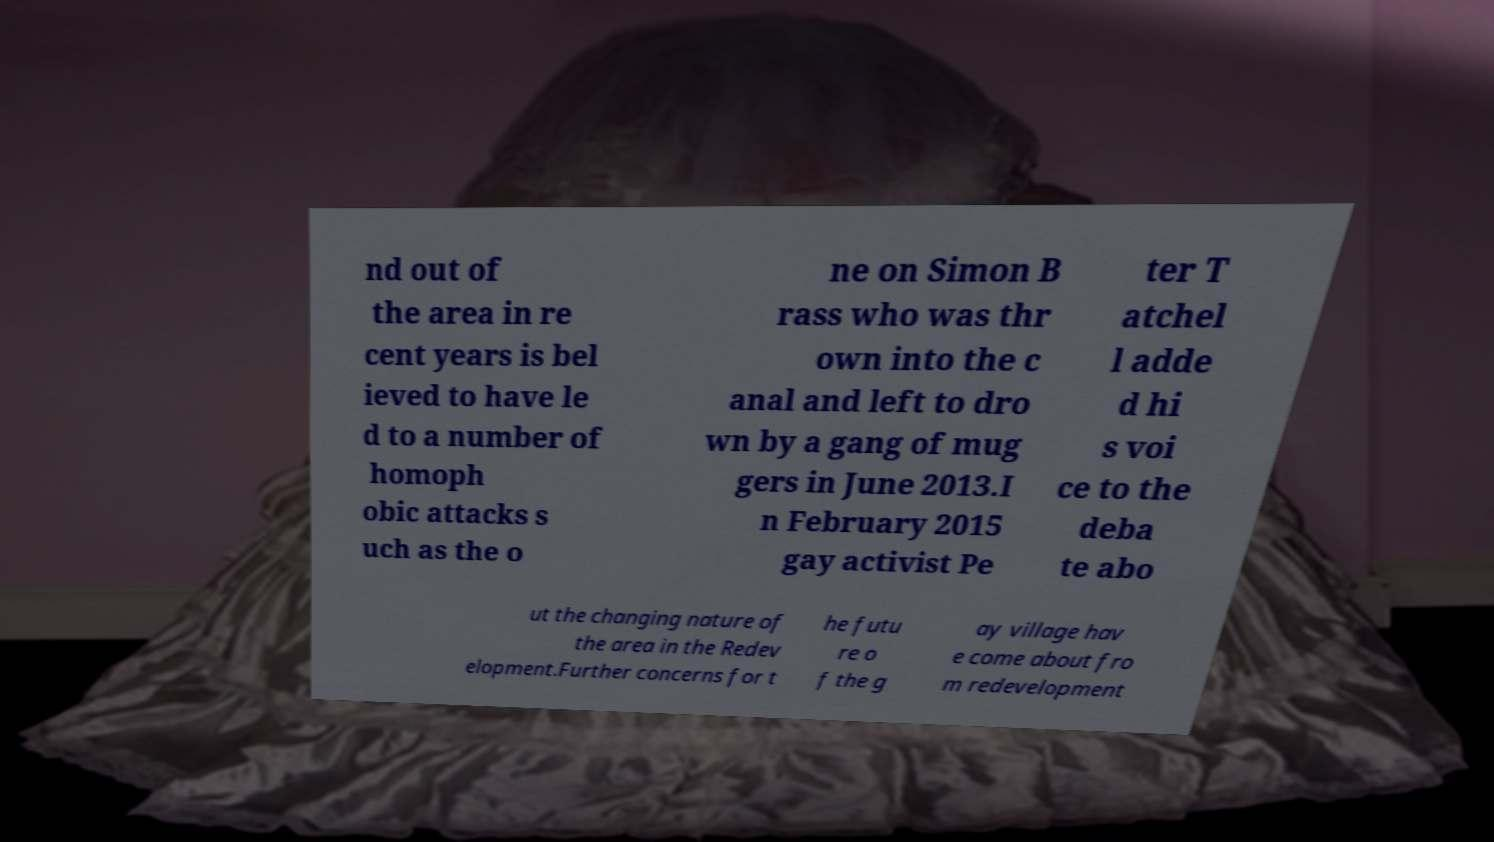Can you read and provide the text displayed in the image?This photo seems to have some interesting text. Can you extract and type it out for me? nd out of the area in re cent years is bel ieved to have le d to a number of homoph obic attacks s uch as the o ne on Simon B rass who was thr own into the c anal and left to dro wn by a gang of mug gers in June 2013.I n February 2015 gay activist Pe ter T atchel l adde d hi s voi ce to the deba te abo ut the changing nature of the area in the Redev elopment.Further concerns for t he futu re o f the g ay village hav e come about fro m redevelopment 